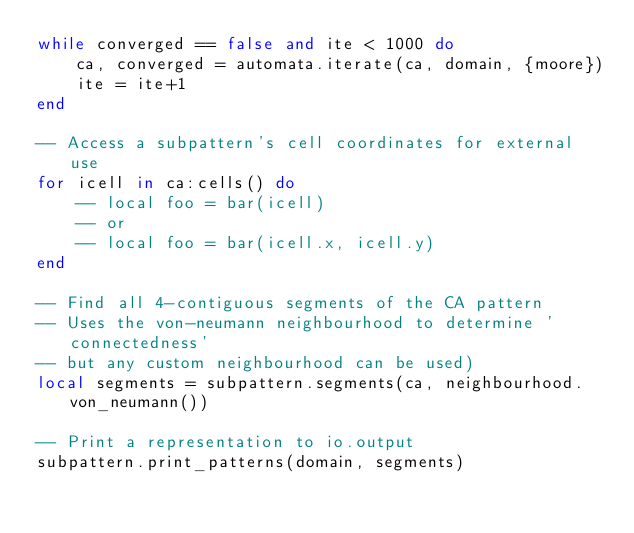<code> <loc_0><loc_0><loc_500><loc_500><_Lua_>while converged == false and ite < 1000 do
    ca, converged = automata.iterate(ca, domain, {moore})
    ite = ite+1
end

-- Access a subpattern's cell coordinates for external use
for icell in ca:cells() do
    -- local foo = bar(icell)
    -- or
    -- local foo = bar(icell.x, icell.y)
end

-- Find all 4-contiguous segments of the CA pattern
-- Uses the von-neumann neighbourhood to determine 'connectedness'
-- but any custom neighbourhood can be used)
local segments = subpattern.segments(ca, neighbourhood.von_neumann())

-- Print a representation to io.output
subpattern.print_patterns(domain, segments)

</code> 